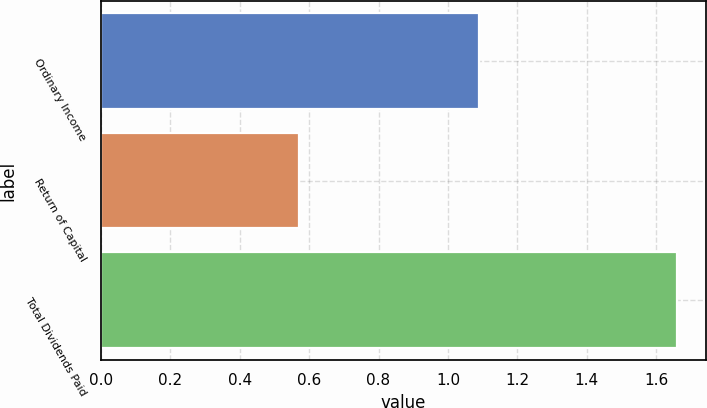Convert chart. <chart><loc_0><loc_0><loc_500><loc_500><bar_chart><fcel>Ordinary Income<fcel>Return of Capital<fcel>Total Dividends Paid<nl><fcel>1.09<fcel>0.57<fcel>1.66<nl></chart> 